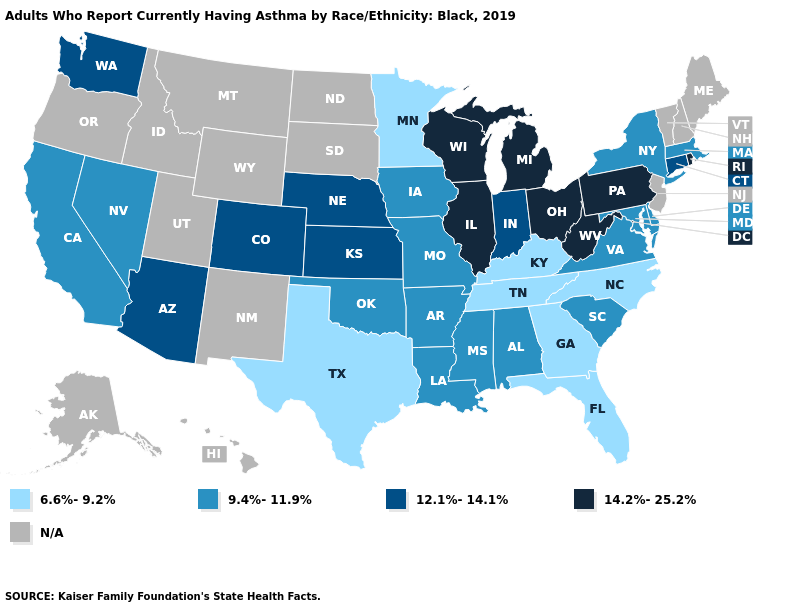Name the states that have a value in the range 12.1%-14.1%?
Quick response, please. Arizona, Colorado, Connecticut, Indiana, Kansas, Nebraska, Washington. Name the states that have a value in the range 12.1%-14.1%?
Concise answer only. Arizona, Colorado, Connecticut, Indiana, Kansas, Nebraska, Washington. What is the lowest value in the USA?
Answer briefly. 6.6%-9.2%. What is the highest value in the USA?
Give a very brief answer. 14.2%-25.2%. Name the states that have a value in the range 12.1%-14.1%?
Quick response, please. Arizona, Colorado, Connecticut, Indiana, Kansas, Nebraska, Washington. Which states have the lowest value in the MidWest?
Concise answer only. Minnesota. Does the first symbol in the legend represent the smallest category?
Concise answer only. Yes. What is the value of California?
Keep it brief. 9.4%-11.9%. Name the states that have a value in the range 9.4%-11.9%?
Give a very brief answer. Alabama, Arkansas, California, Delaware, Iowa, Louisiana, Maryland, Massachusetts, Mississippi, Missouri, Nevada, New York, Oklahoma, South Carolina, Virginia. What is the value of New Hampshire?
Keep it brief. N/A. Which states have the lowest value in the South?
Quick response, please. Florida, Georgia, Kentucky, North Carolina, Tennessee, Texas. Name the states that have a value in the range 6.6%-9.2%?
Short answer required. Florida, Georgia, Kentucky, Minnesota, North Carolina, Tennessee, Texas. What is the value of Rhode Island?
Give a very brief answer. 14.2%-25.2%. 